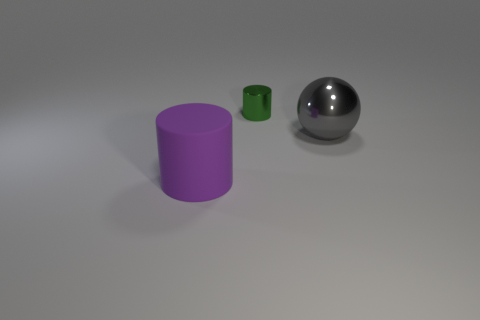Add 3 tiny red balls. How many objects exist? 6 Subtract all cylinders. How many objects are left? 1 Add 1 cyan things. How many cyan things exist? 1 Subtract 0 cyan spheres. How many objects are left? 3 Subtract all large green cylinders. Subtract all purple rubber cylinders. How many objects are left? 2 Add 3 large gray metallic spheres. How many large gray metallic spheres are left? 4 